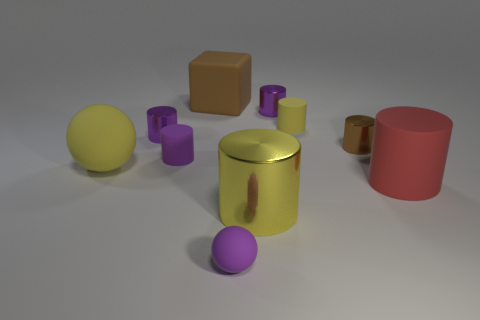What is the size of the brown metal thing that is the same shape as the large yellow metal thing?
Your answer should be compact. Small. Do the large yellow thing on the left side of the large brown matte thing and the small purple object that is in front of the large rubber cylinder have the same material?
Your response must be concise. Yes. Are there fewer brown objects to the right of the brown matte thing than red shiny cubes?
Your answer should be very brief. No. Are there any other things that are the same shape as the brown rubber thing?
Provide a short and direct response. No. The big shiny object that is the same shape as the small brown thing is what color?
Your answer should be compact. Yellow. There is a yellow cylinder behind the yellow ball; is it the same size as the tiny rubber ball?
Provide a succinct answer. Yes. How big is the matte sphere that is in front of the yellow cylinder in front of the tiny yellow rubber cylinder?
Your response must be concise. Small. Does the large brown object have the same material as the purple cylinder that is in front of the brown metal object?
Make the answer very short. Yes. Are there fewer small yellow matte objects on the left side of the big rubber ball than brown blocks that are to the right of the large red cylinder?
Provide a short and direct response. No. What is the color of the other sphere that is made of the same material as the yellow ball?
Make the answer very short. Purple. 